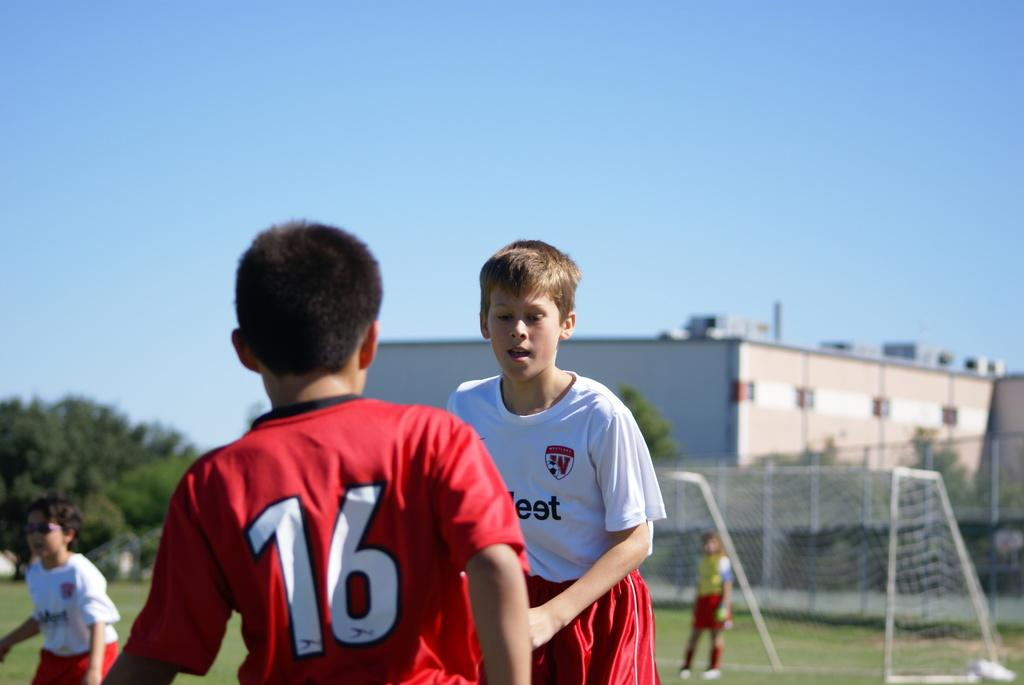How many people are playing in the image? There are four people playing in the image. Where are the people playing? The people are playing on a ground. What can be seen in the background of the image? There is a building and trees visible in the image. What is the color of the grass in the image? The grass in the image is green. What equipment is being used for the game? There is a football net in the image. How many docks are visible in the image? There are no docks present in the image. What is the selection of fruits available in the image? There is no mention of fruits in the image; it features people playing on a ground with a football net. 